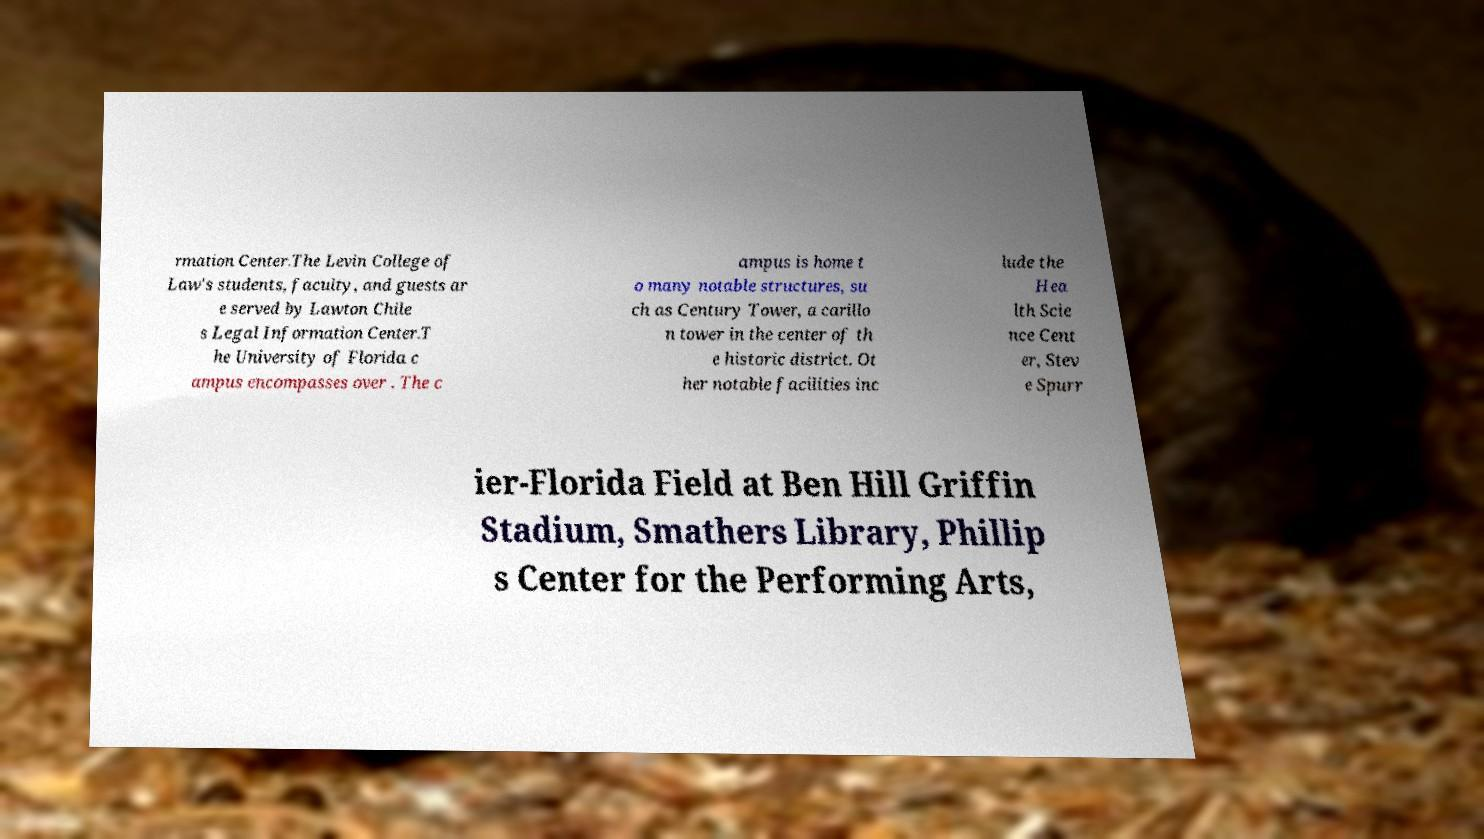Could you extract and type out the text from this image? rmation Center.The Levin College of Law's students, faculty, and guests ar e served by Lawton Chile s Legal Information Center.T he University of Florida c ampus encompasses over . The c ampus is home t o many notable structures, su ch as Century Tower, a carillo n tower in the center of th e historic district. Ot her notable facilities inc lude the Hea lth Scie nce Cent er, Stev e Spurr ier-Florida Field at Ben Hill Griffin Stadium, Smathers Library, Phillip s Center for the Performing Arts, 